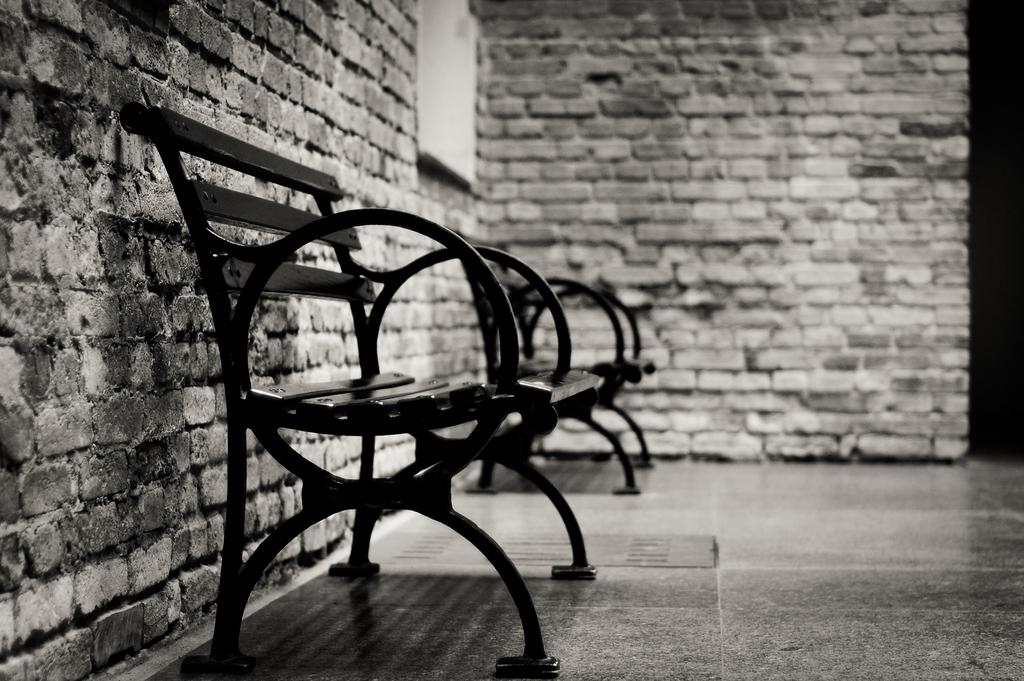What type of seating is visible in the image? There are benches in the image. What material are the walls made of in the image? The walls in the image are made of bricks. What type of polish is being applied to the benches in the image? There is no indication in the image that any polish is being applied to the benches. How many times do the people in the image shake hands with each other? There are no people visible in the image, so it is impossible to determine how many times they might shake hands. 